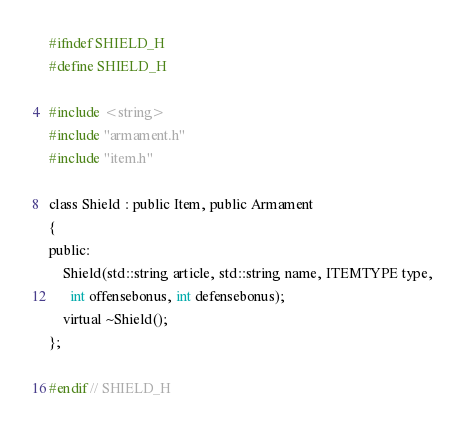Convert code to text. <code><loc_0><loc_0><loc_500><loc_500><_C_>#ifndef SHIELD_H
#define SHIELD_H

#include <string>
#include "armament.h"
#include "item.h"

class Shield : public Item, public Armament
{
public:
    Shield(std::string article, std::string name, ITEMTYPE type,
      int offensebonus, int defensebonus);
    virtual ~Shield();
};

#endif // SHIELD_H
</code> 